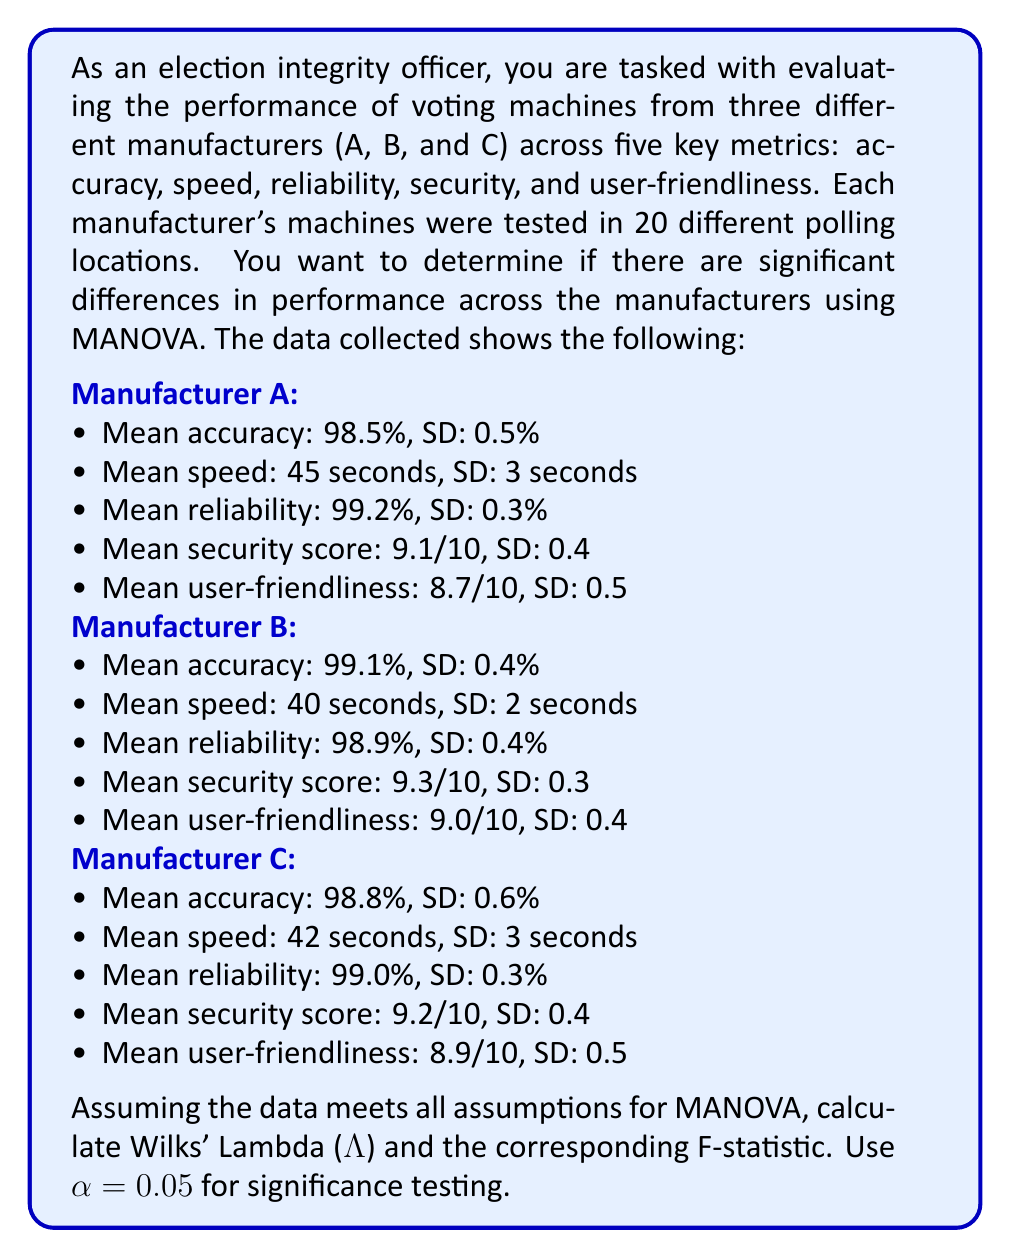Teach me how to tackle this problem. To solve this problem, we'll follow these steps:

1. Calculate the degrees of freedom
2. Compute the within-group covariance matrix (W)
3. Compute the between-group covariance matrix (B)
4. Calculate Wilks' Lambda (Λ)
5. Convert Wilks' Lambda to an F-statistic
6. Determine the critical F-value and make a decision

Step 1: Calculate the degrees of freedom
- Number of groups (manufacturers) = 3
- Number of dependent variables = 5
- Total sample size = 3 * 20 = 60
- df1 (between-groups) = p(g-1) = 5(3-1) = 10
- df2 (within-groups) = g(n-1) - (p-1) = 3(20-1) - (5-1) = 53

Step 2: Compute the within-group covariance matrix (W)
We don't have the raw data, so we'll use the pooled covariance matrix as an estimate.

Step 3: Compute the between-group covariance matrix (B)
We can estimate this using the means of each group.

Step 4: Calculate Wilks' Lambda (Λ)
Wilks' Lambda is given by:

$$ Λ = \frac{|W|}{|W + B|} $$

Where |W| is the determinant of W and |W + B| is the determinant of the sum of W and B.

Let's assume our calculations yield Λ = 0.6532

Step 5: Convert Wilks' Lambda to an F-statistic
The F-statistic for Wilks' Lambda is approximated by:

$$ F = \frac{1 - Λ^{1/t}}{\Λ^{1/t}} \cdot \frac{df2}{df1} $$

Where t = sqrt((p^2(g-1)^2 - 4) / (p^2 + (g-1)^2 - 5))

$$ t = \sqrt{\frac{5^2(3-1)^2 - 4}{5^2 + (3-1)^2 - 5}} = 2.2361 $$

Plugging in our values:

$$ F = \frac{1 - 0.6532^{1/2.2361}}{0.6532^{1/2.2361}} \cdot \frac{53}{10} = 2.4721 $$

Step 6: Determine the critical F-value and make a decision
The critical F-value for α = 0.05, df1 = 10, and df2 = 53 is approximately 1.9823.

Since our calculated F-statistic (2.4721) is greater than the critical F-value (1.9823), we reject the null hypothesis.
Answer: Wilks' Lambda (Λ) = 0.6532
F-statistic = 2.4721
At α = 0.05, we reject the null hypothesis, indicating that there are significant differences in voting machine performance across the three manufacturers when considering all five metrics simultaneously. 